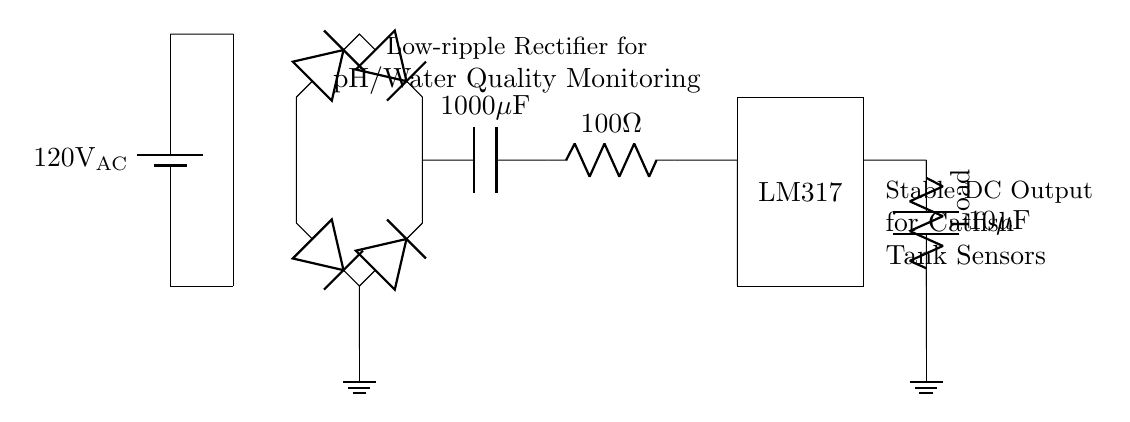What is the input voltage of the circuit? The input voltage is indicated as 120V AC, which is shown next to the battery symbol in the circuit diagram.
Answer: 120V AC What type of rectifier is used in this circuit? The circuit employs a bridge rectifier configuration, which consists of four diodes arranged to convert AC voltage into DC voltage.
Answer: Bridge rectifier What is the capacitance value of the main filter capacitor? The main filter capacitor is labeled as 1000 microfarads, which is specified next to the capacitor symbol in the circuit diagram.
Answer: 1000 microfarads What is the purpose of the LM317 in this circuit? The LM317 is a voltage regulator component that maintains a stable output voltage, which is necessary for the pH and water quality monitoring devices to function accurately.
Answer: Voltage regulator What is the resistance value connected to the capacitor? The resistance value shown next to the resistor is 100 ohms, which is intended to work with the capacitor for filtering.
Answer: 100 ohms How does the capacitor influence the circuit's performance? The capacitor smooths the output voltage by reducing ripple; it stores charge and releases it to maintain a steady DC voltage, which is crucial for sensitive sensors.
Answer: Reduces ripple 